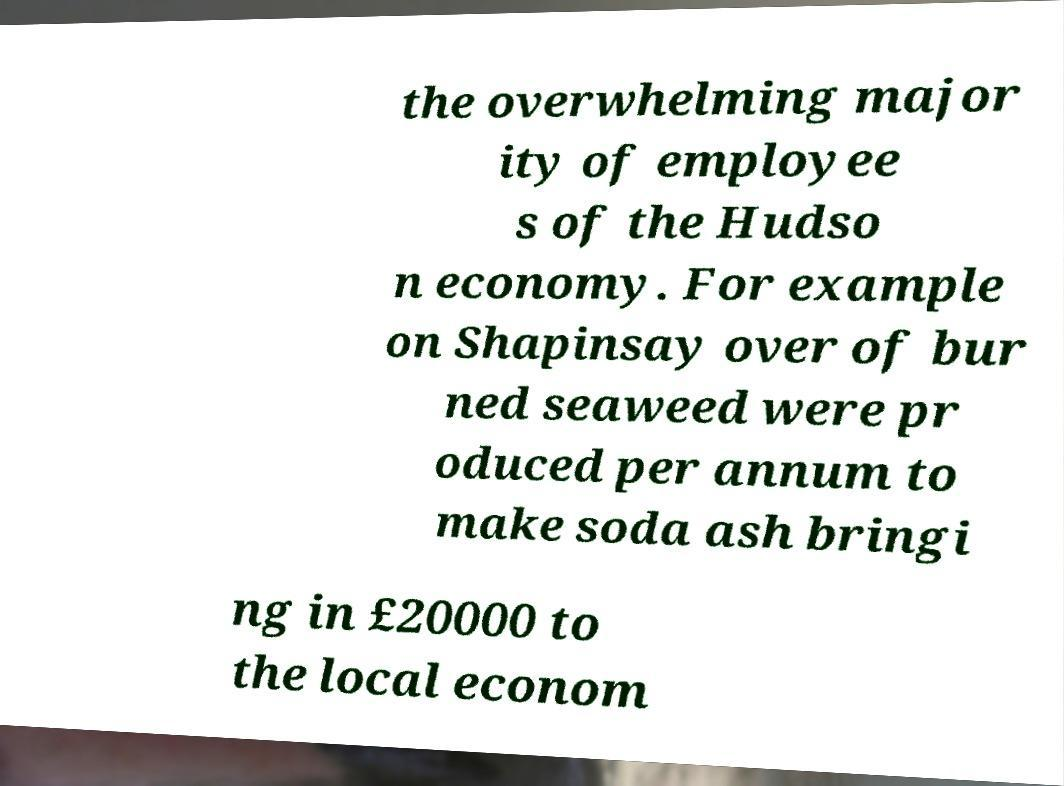Could you extract and type out the text from this image? the overwhelming major ity of employee s of the Hudso n economy. For example on Shapinsay over of bur ned seaweed were pr oduced per annum to make soda ash bringi ng in £20000 to the local econom 